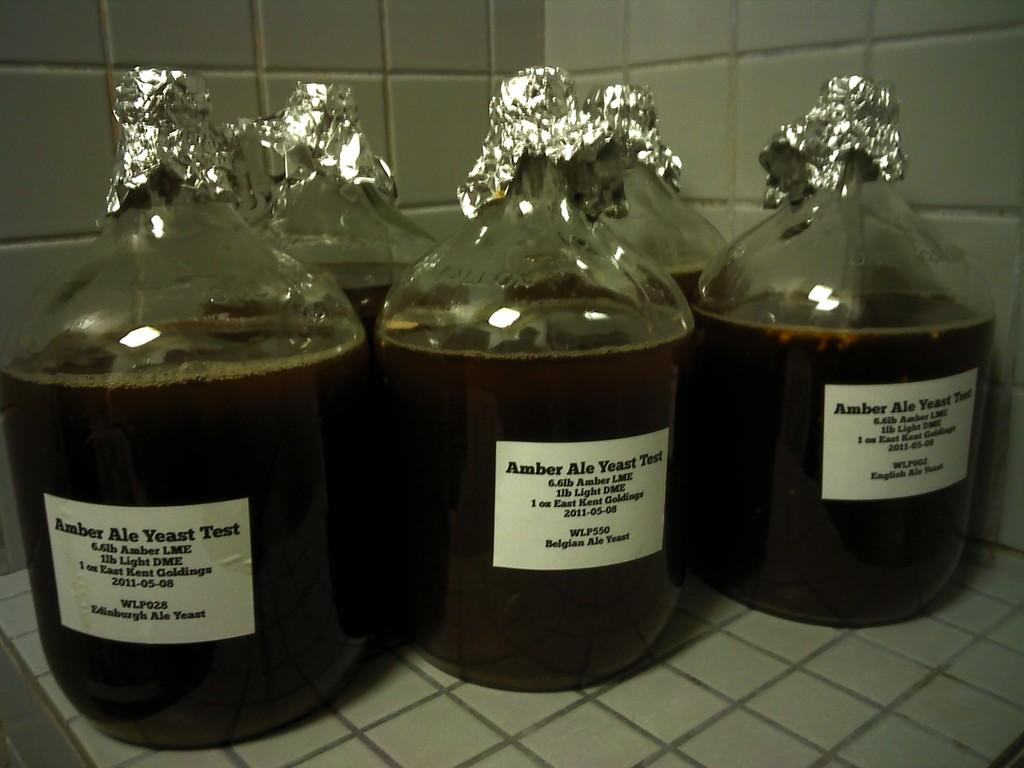<image>
Relay a brief, clear account of the picture shown. 3 identical bottles of the drink Amber Ale Yeast 